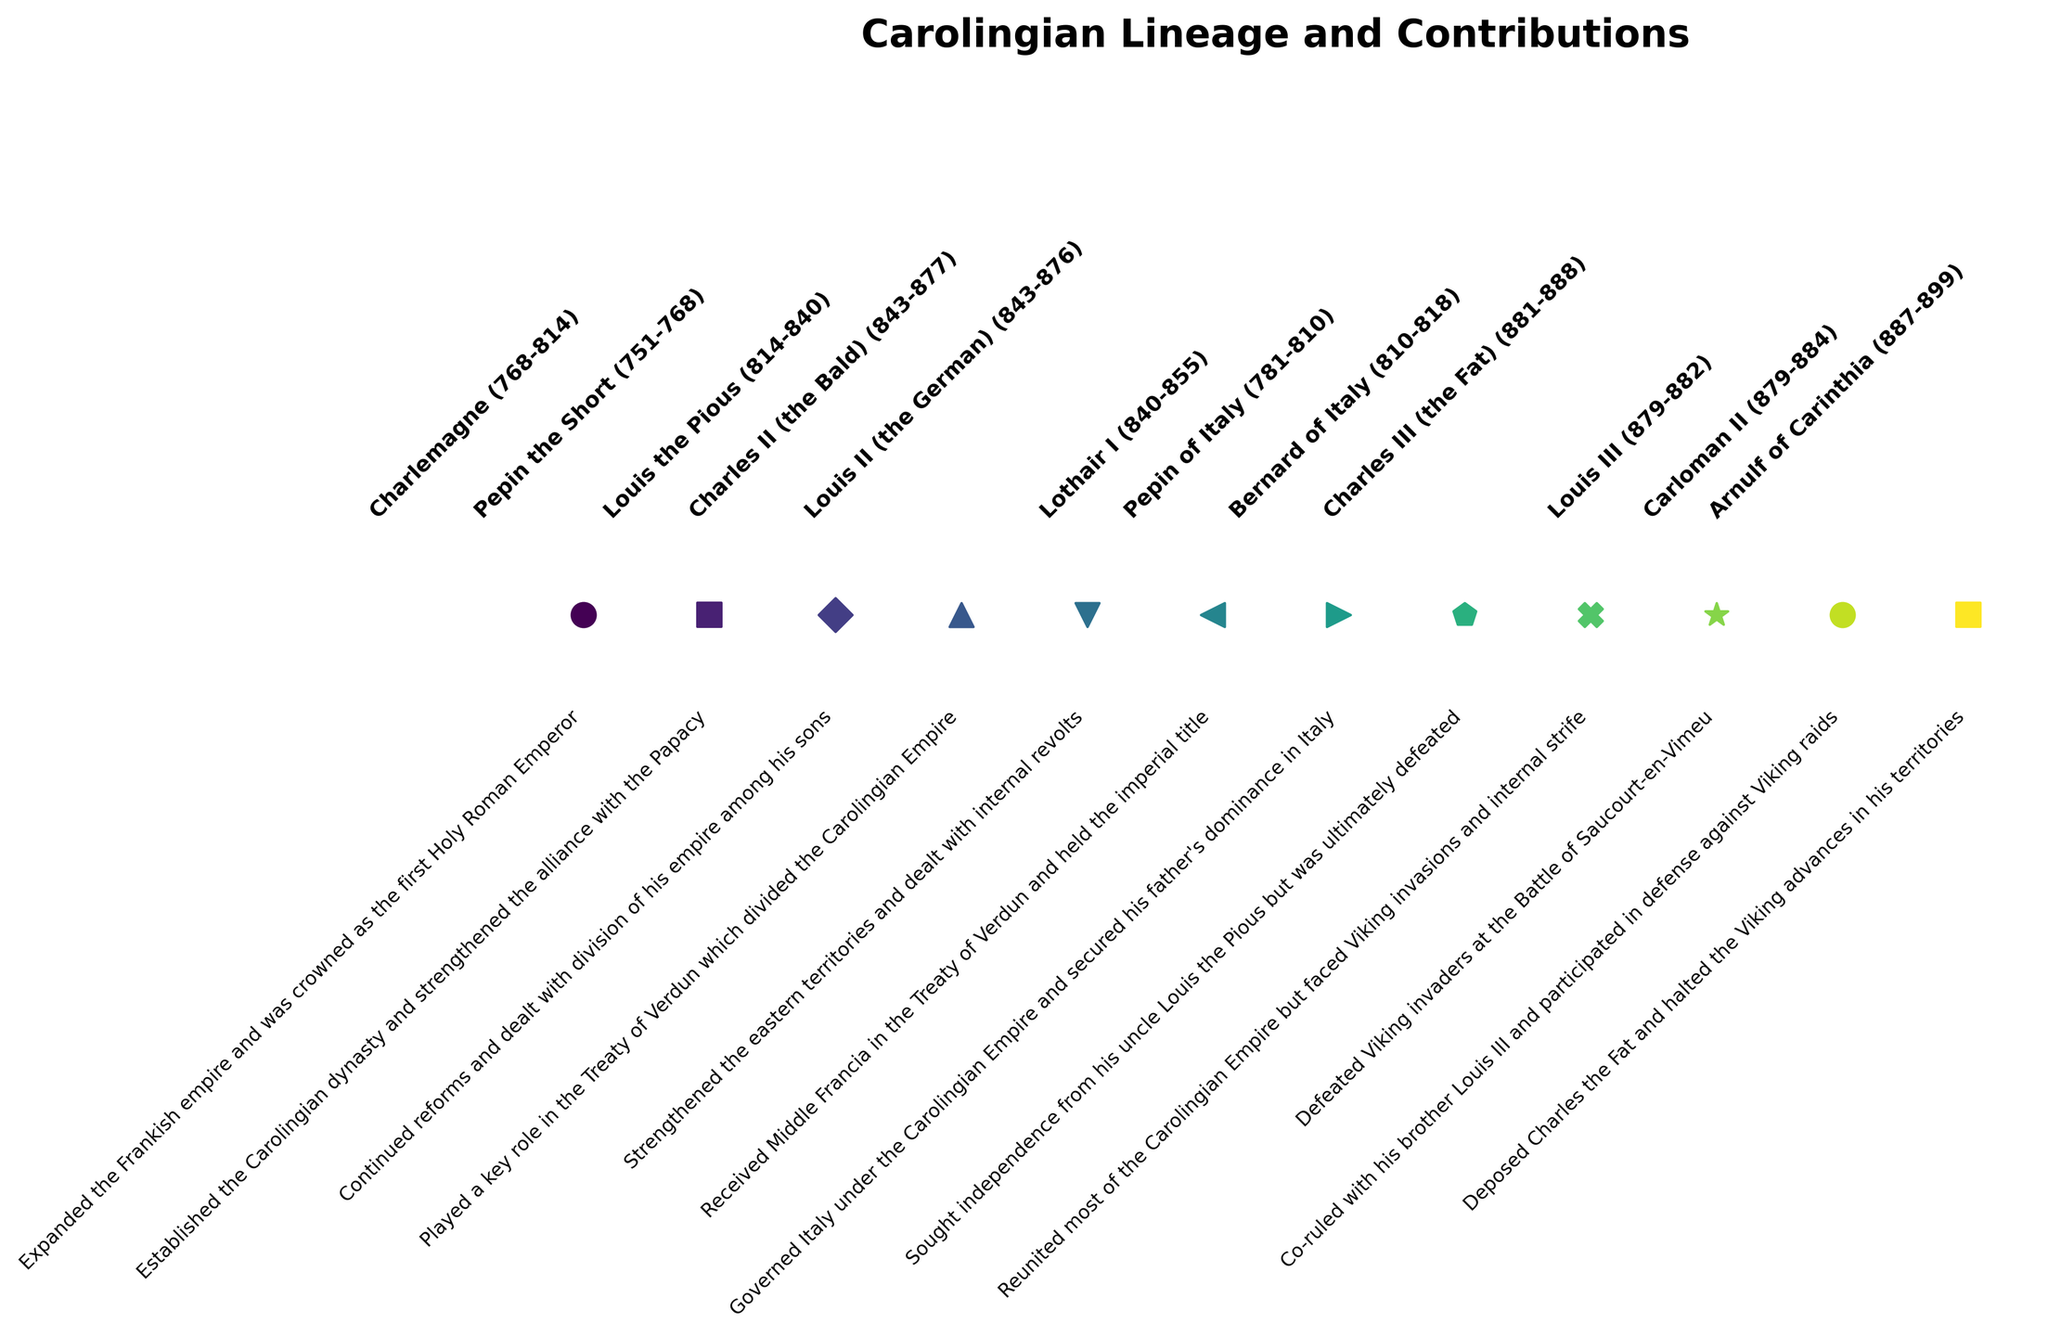Which Carolingian figure had the longest reign? To determine this, we need to check the "Reign" durations provided in the annotations and compare them. We find that Charlemagne reigned from 768 to 814. Calculating the duration, we get 46 years, which is the longest reign among the listed figures.
Answer: Charlemagne Who played a key role in the Treaty of Verdun? Looking at the text annotations in the figure, Charles II (the Bald) is noted for playing a key role in the Treaty of Verdun.
Answer: Charles II (the Bald) Which figures are indicated as having dealt with Viking invasions? By reviewing the contributions mentioned in the text annotations, we see that Louis III and Arnulf of Carinthia are both noted for dealing with Viking invasions.
Answer: Louis III and Arnulf of Carinthia Who reigned simultaneously as co-rulers in West Francia? From the figure annotations, we observe that Louis III and Carloman II co-ruled West Francia.
Answer: Louis III and Carloman II Which ruler's title was "King of the Lombards" before being crowned Emperor? Scanning the textual annotations, Pepin of Italy is identified as "King of the Lombards" and later was part of the Carolingian Empire.
Answer: Pepin of Italy Which Carolingian descendant was crowned the first Holy Roman Emperor? According to the annotations, Charlemagne was crowned the first Holy Roman Emperor.
Answer: Charlemagne 